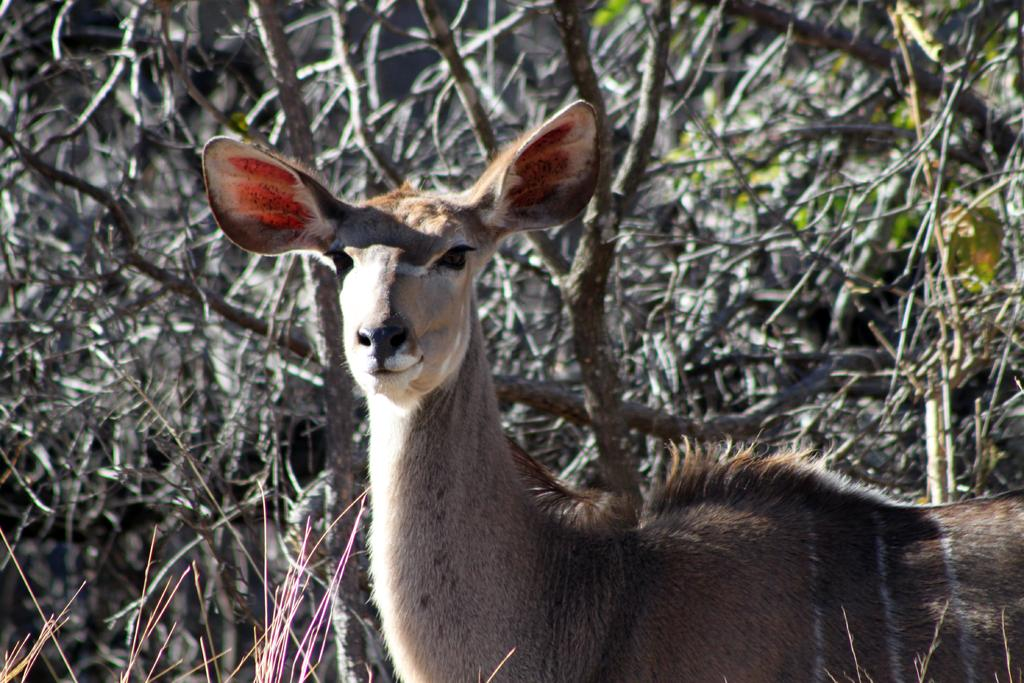What type of creature is present in the image? There is an animal in the image. Can you describe the color of the animal? The animal has a brown and pale brown color. What else can be seen in the image besides the animal? There are branches and leaves in the image. What type of bun is being used to brush the sail in the image? There is no bun, sail, or brushing activity present in the image. 